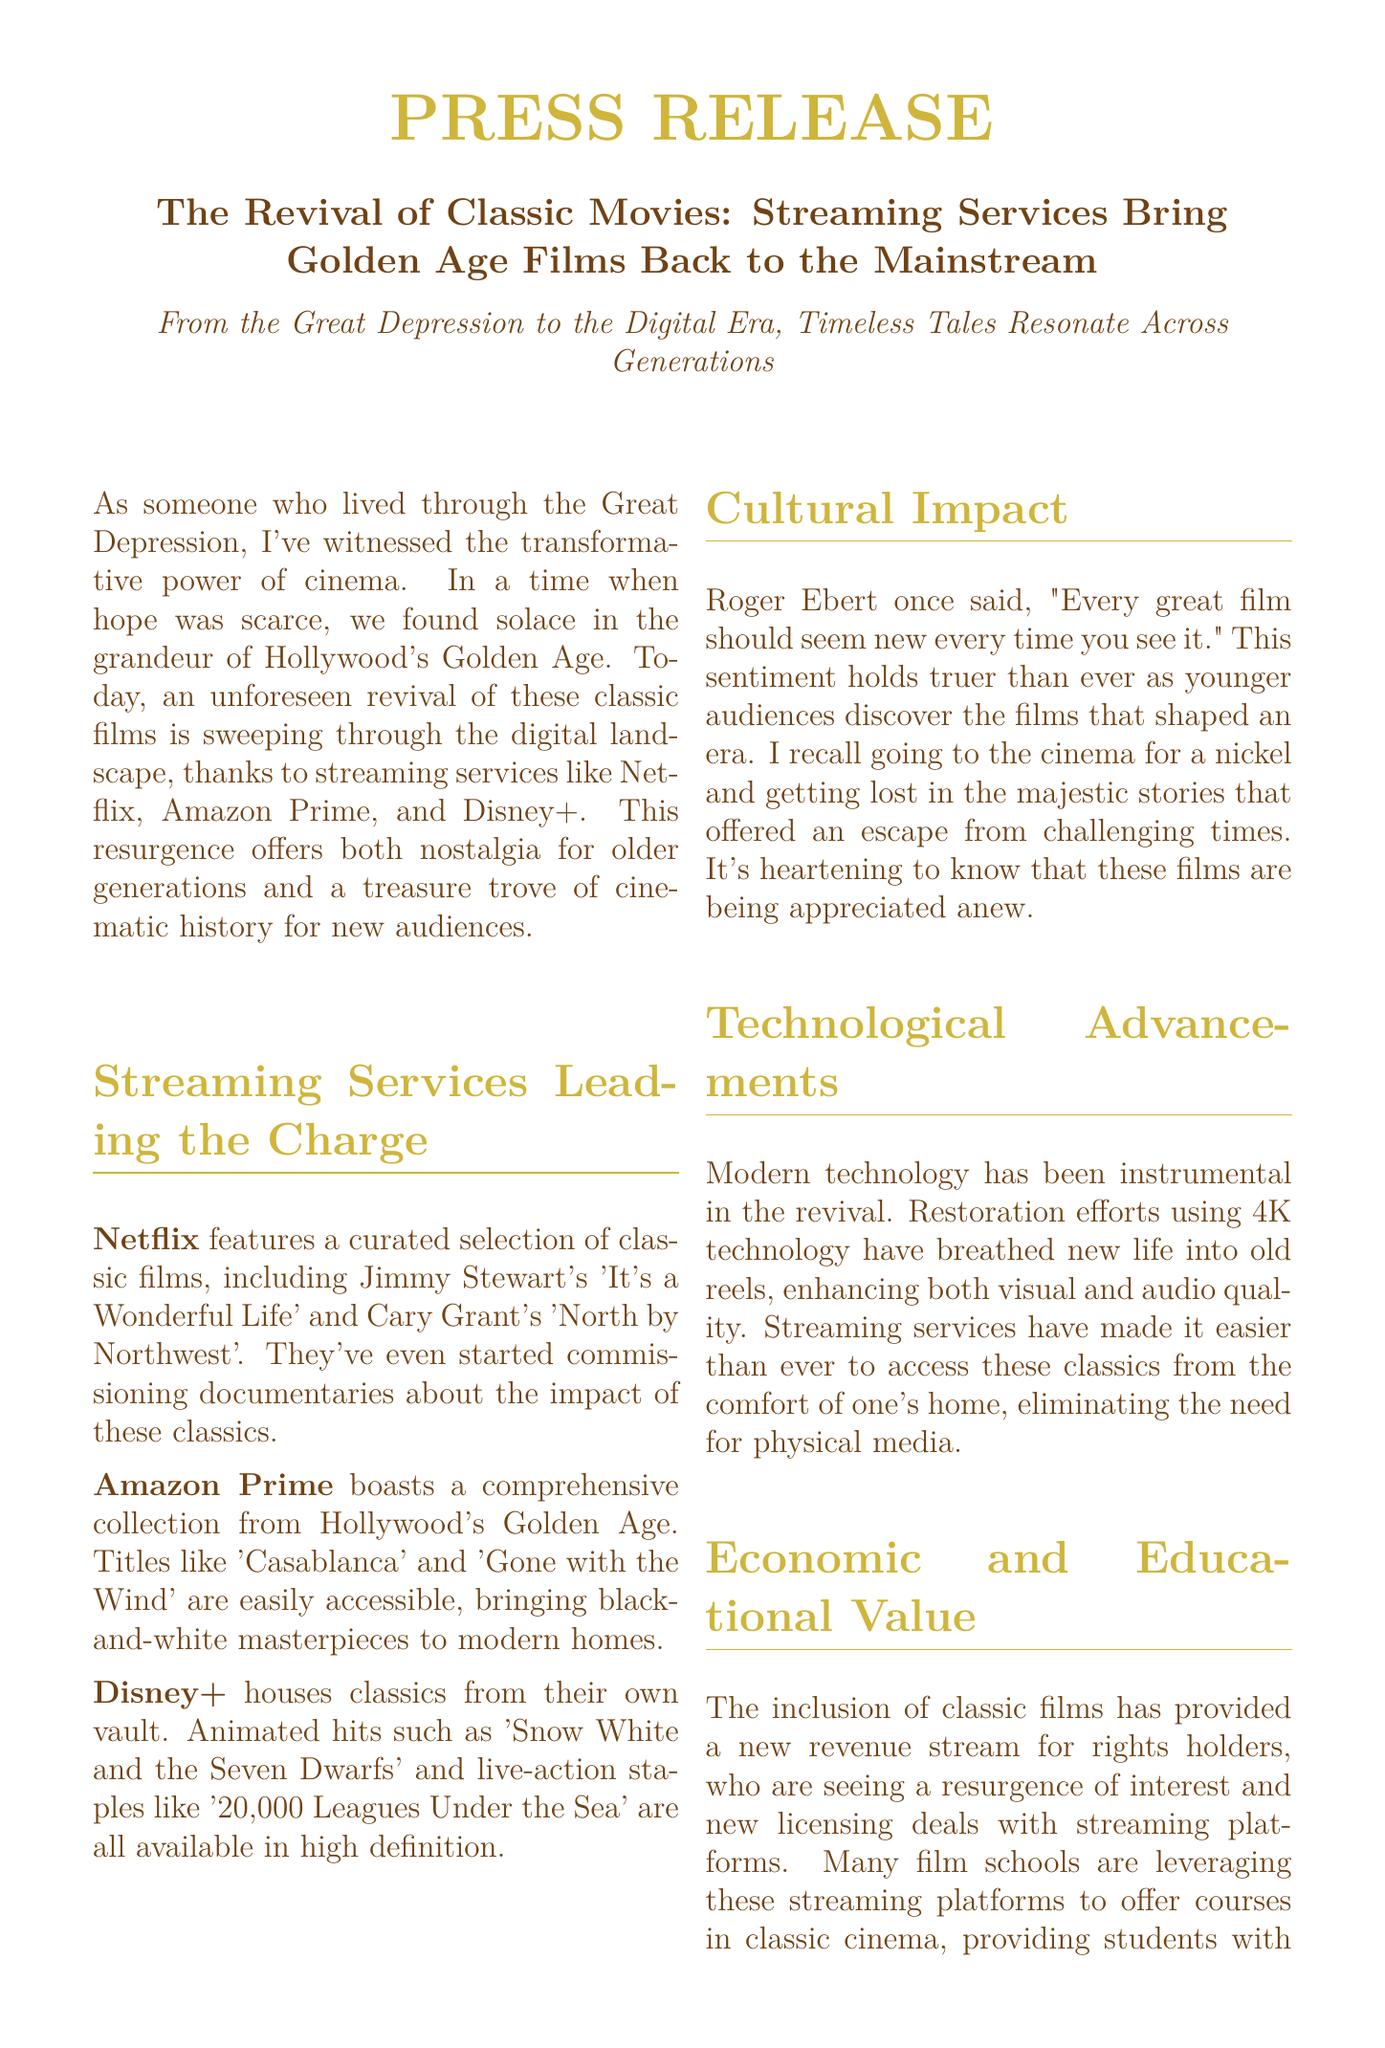what is the title of the press release? The title is clearly stated at the beginning of the document, focusing on classic movies and streaming services.
Answer: The Revival of Classic Movies: Streaming Services Bring Golden Age Films Back to the Mainstream which streaming service features 'It's a Wonderful Life'? The document specifies that Netflix features this classic film among its selections.
Answer: Netflix name one classic film available on Amazon Prime. The document lists 'Casablanca' as an example of a classic film that is part of Amazon Prime's collection.
Answer: Casablanca who is quoted in the document regarding the perception of great films? The document mentions Roger Ebert's sentiment about great films seeming new upon every viewing.
Answer: Roger Ebert what technology has been used to enhance old film reels? The document discusses the use of modern technology, particularly 4K technology, for restoration efforts.
Answer: 4K technology how does the inclusion of classic films benefit rights holders? The document explains that the inclusion has created a new revenue stream through increased interest and licensing deals.
Answer: New revenue stream what is one educational use of streaming platforms mentioned in the document? The document points out that film schools use these platforms to offer courses in classic cinema.
Answer: Offer courses in classic cinema how does the document describe the connection between past and present through films? It states that the revival serves as a bridge, connecting historical stories to modern audiences today.
Answer: A bridge between the past and the present 